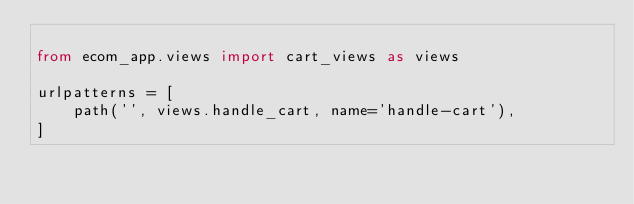<code> <loc_0><loc_0><loc_500><loc_500><_Python_>
from ecom_app.views import cart_views as views

urlpatterns = [
    path('', views.handle_cart, name='handle-cart'),
]
</code> 